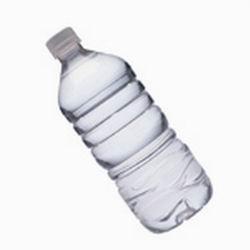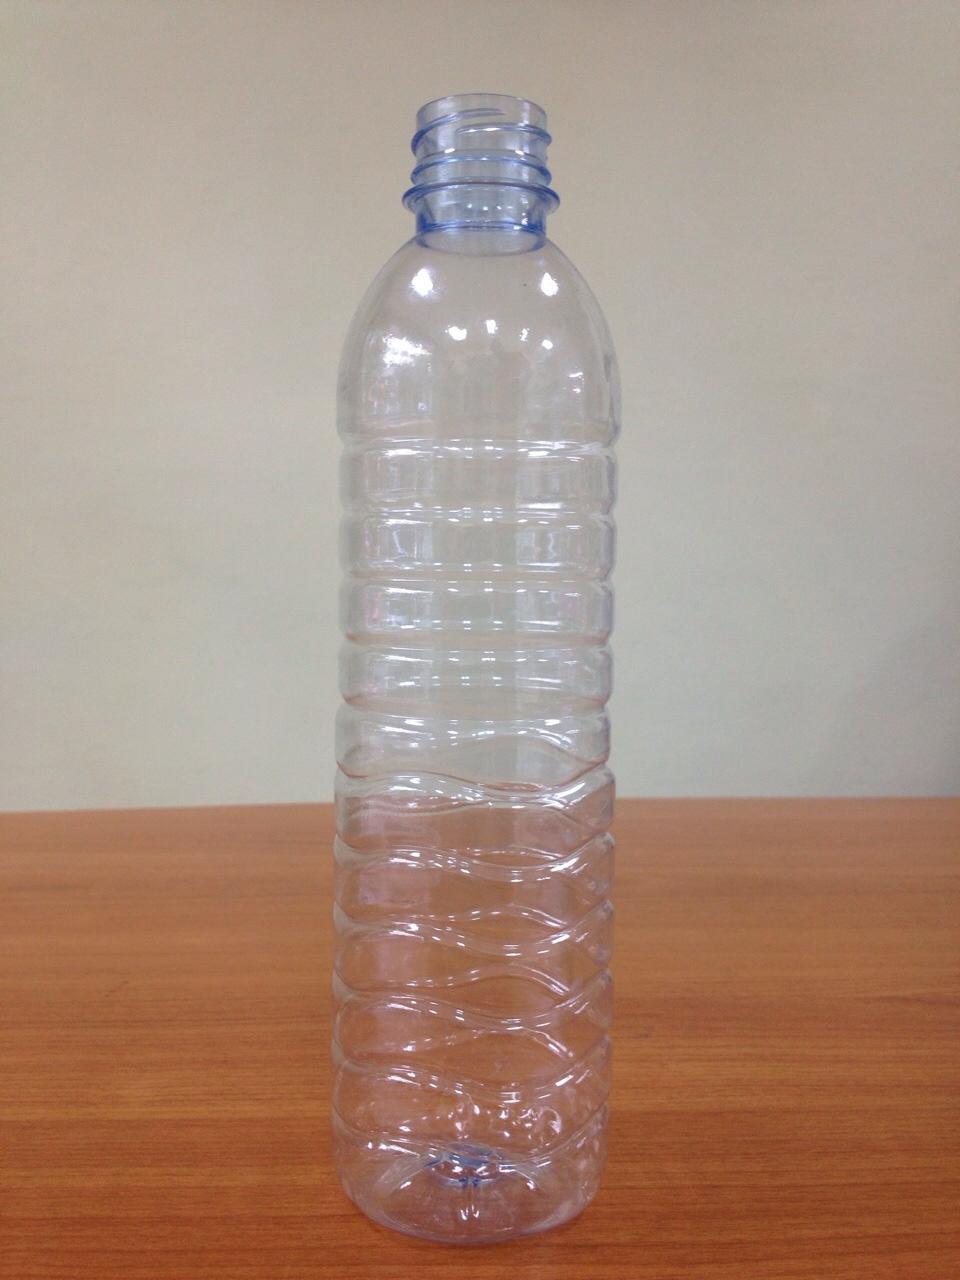The first image is the image on the left, the second image is the image on the right. Examine the images to the left and right. Is the description "There is a reusable water bottle on the left and a disposable bottle on the right." accurate? Answer yes or no. No. The first image is the image on the left, the second image is the image on the right. Evaluate the accuracy of this statement regarding the images: "The bottle caps are all blue.". Is it true? Answer yes or no. No. 